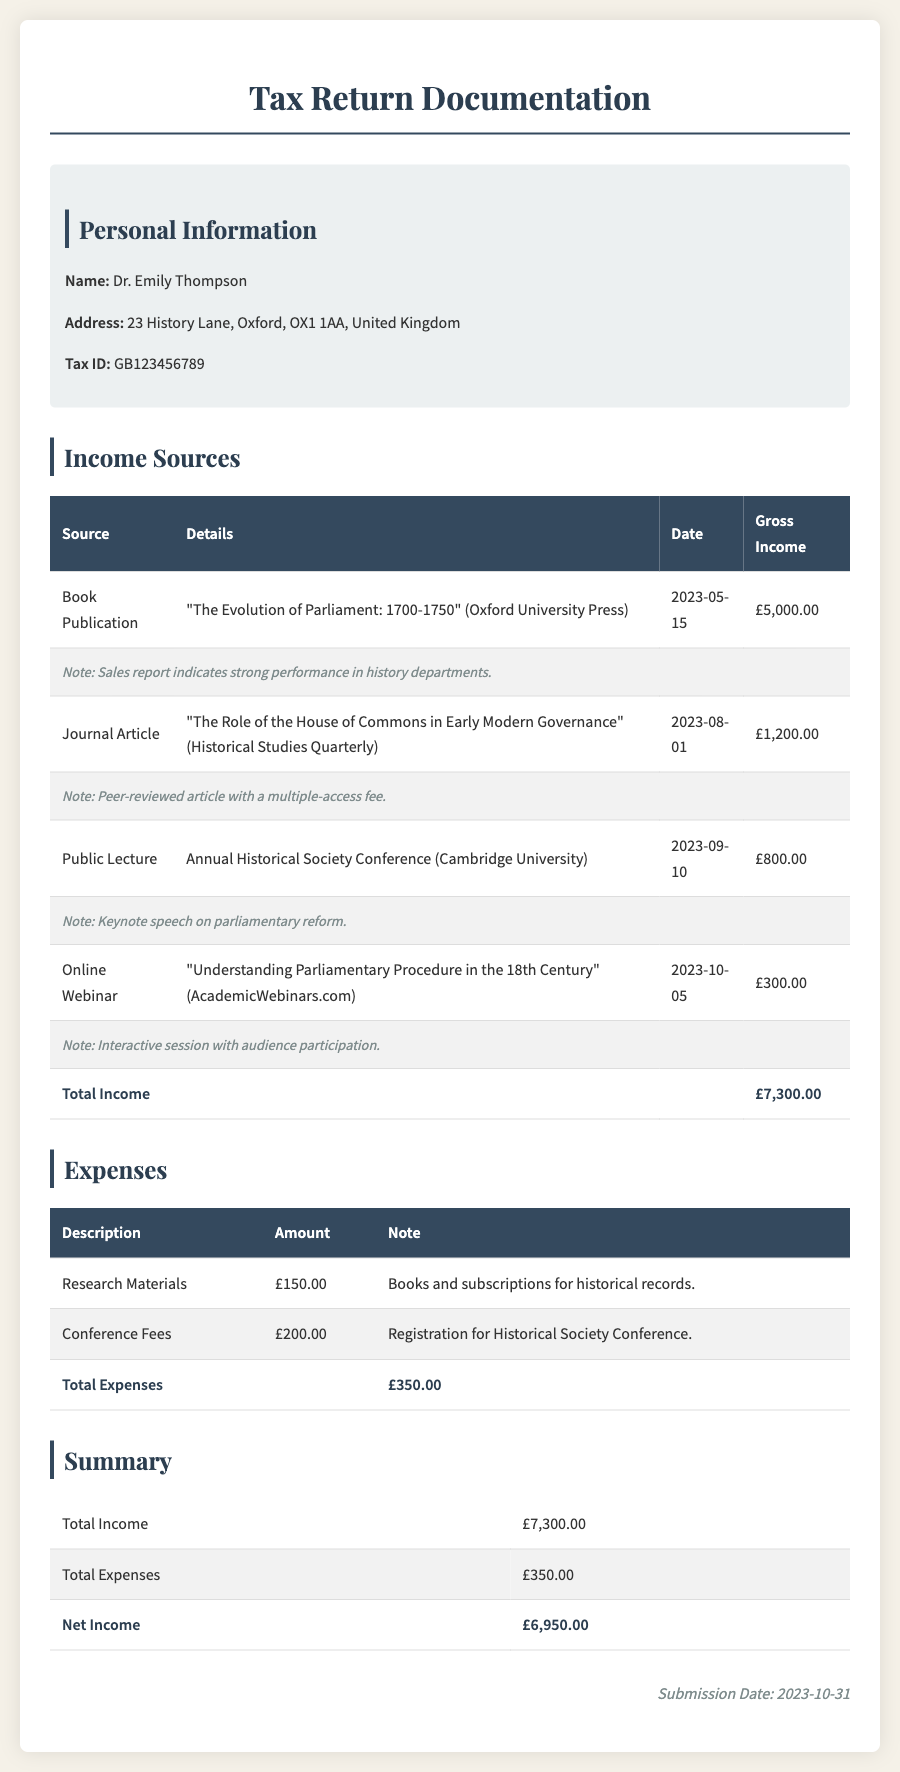What is the total income? The total income is calculated by adding all gross income from different sources together, which is £5,000.00 + £1,200.00 + £800.00 + £300.00 = £7,300.00.
Answer: £7,300.00 What is Dr. Emily Thompson's tax ID? The tax ID is a specific identifier for tax purposes that indicates the individual, which is found in the personal information section of the document.
Answer: GB123456789 When was the book publication? The date of the book publication is given in the income sources section, which lists the specific date for that income source.
Answer: 2023-05-15 What was the income from the public lecture? The amount earned from the public lecture can be found in the income sources section, specifically under that income type.
Answer: £800.00 What is the total expense? The total expense is calculated by summing the amounts from the expense section, which is £150.00 + £200.00 = £350.00.
Answer: £350.00 What was the net income? The net income is determined by subtracting total expenses from total income, as shown in the summary section of the document.
Answer: £6,950.00 What is the title of the book published? The title of the book is specified in the income sources section, which indicates the nature of that publication.
Answer: The Evolution of Parliament: 1700-1750 What type of event was held on 2023-10-05? The date corresponds to an event listed in the income section, and identifies the nature of that event it's referred to.
Answer: Online Webinar What is the submission date? The submission date is provided at the end of the document, indicating when the tax return documentation was submitted.
Answer: 2023-10-31 